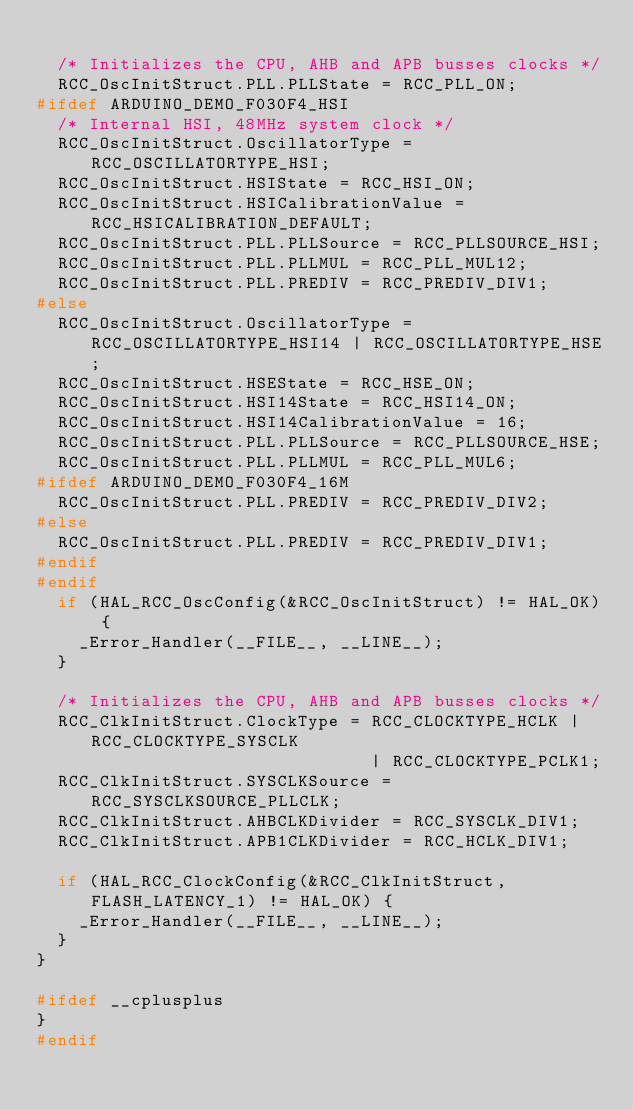<code> <loc_0><loc_0><loc_500><loc_500><_C++_>
  /* Initializes the CPU, AHB and APB busses clocks */
  RCC_OscInitStruct.PLL.PLLState = RCC_PLL_ON;
#ifdef ARDUINO_DEMO_F030F4_HSI
  /* Internal HSI, 48MHz system clock */
  RCC_OscInitStruct.OscillatorType = RCC_OSCILLATORTYPE_HSI;
  RCC_OscInitStruct.HSIState = RCC_HSI_ON;
  RCC_OscInitStruct.HSICalibrationValue = RCC_HSICALIBRATION_DEFAULT;
  RCC_OscInitStruct.PLL.PLLSource = RCC_PLLSOURCE_HSI;
  RCC_OscInitStruct.PLL.PLLMUL = RCC_PLL_MUL12;
  RCC_OscInitStruct.PLL.PREDIV = RCC_PREDIV_DIV1;
#else
  RCC_OscInitStruct.OscillatorType = RCC_OSCILLATORTYPE_HSI14 | RCC_OSCILLATORTYPE_HSE;
  RCC_OscInitStruct.HSEState = RCC_HSE_ON;
  RCC_OscInitStruct.HSI14State = RCC_HSI14_ON;
  RCC_OscInitStruct.HSI14CalibrationValue = 16;
  RCC_OscInitStruct.PLL.PLLSource = RCC_PLLSOURCE_HSE;
  RCC_OscInitStruct.PLL.PLLMUL = RCC_PLL_MUL6;
#ifdef ARDUINO_DEMO_F030F4_16M
  RCC_OscInitStruct.PLL.PREDIV = RCC_PREDIV_DIV2;
#else
  RCC_OscInitStruct.PLL.PREDIV = RCC_PREDIV_DIV1;
#endif
#endif
  if (HAL_RCC_OscConfig(&RCC_OscInitStruct) != HAL_OK) {
    _Error_Handler(__FILE__, __LINE__);
  }

  /* Initializes the CPU, AHB and APB busses clocks */
  RCC_ClkInitStruct.ClockType = RCC_CLOCKTYPE_HCLK | RCC_CLOCKTYPE_SYSCLK
                                | RCC_CLOCKTYPE_PCLK1;
  RCC_ClkInitStruct.SYSCLKSource = RCC_SYSCLKSOURCE_PLLCLK;
  RCC_ClkInitStruct.AHBCLKDivider = RCC_SYSCLK_DIV1;
  RCC_ClkInitStruct.APB1CLKDivider = RCC_HCLK_DIV1;

  if (HAL_RCC_ClockConfig(&RCC_ClkInitStruct, FLASH_LATENCY_1) != HAL_OK) {
    _Error_Handler(__FILE__, __LINE__);
  }
}

#ifdef __cplusplus
}
#endif
</code> 